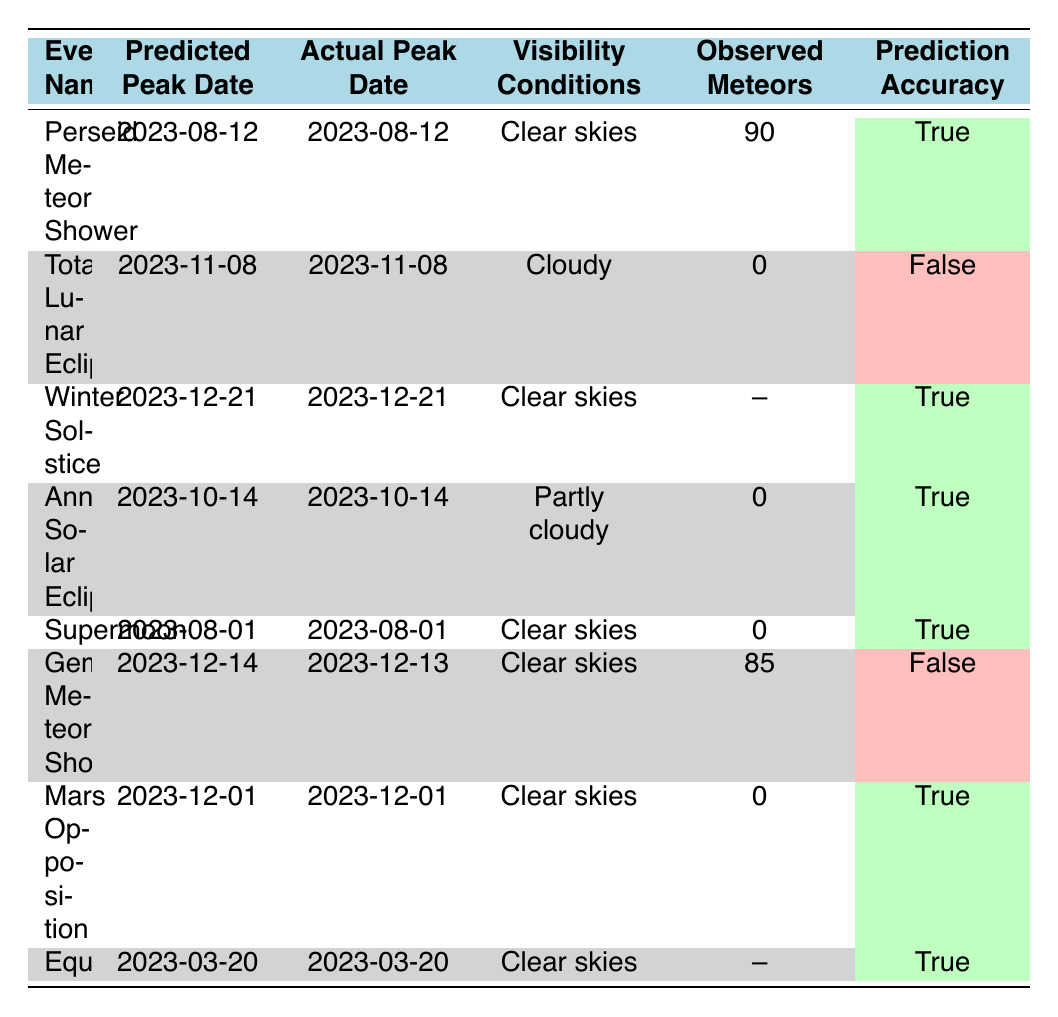What is the predicted peak date for the Perseid Meteor Shower? The table shows that the predicted peak date for the Perseid Meteor Shower is listed under the "Predicted Peak Date" column for that event.
Answer: 2023-08-12 How many observed meteors were noted during the Annular Solar Eclipse? According to the table, the number of observed meteors during the Annular Solar Eclipse is recorded in the "Observed Meteors" column, which states 0.
Answer: 0 Which celestial event had true prediction accuracy but faced cloudy visibility conditions? The "Total Lunar Eclipse" event has a prediction accuracy of false despite being accurately predicted to occur on 2023-11-08; however, it had cloudy visibility conditions.
Answer: Total Lunar Eclipse What is the difference in observed meteors between the Perseid Meteor Shower and the Geminid Meteor Shower? The Perseid Meteor Shower had 90 observed meteors, while the Geminid Meteor Shower had 85 observed meteors. To find the difference, subtract the latter from the former: 90 - 85 = 5.
Answer: 5 How many events had clear skies as visibility conditions? Looking at the visibility conditions for all events in the table, we see that the following events had clear skies: Perseid Meteor Shower, Winter Solstice, Mars Opposition, and Equinox, totaling 4 events.
Answer: 4 Was the actual peak date for the Geminid Meteor Shower different from its predicted peak date? The actual peak date for the Geminid Meteor Shower is listed as 2023-12-13, while the predicted peak date was 2023-12-14, indicating they are different dates.
Answer: Yes How many celestial events predicted had a successful accuracy rating? By counting the entries marked as 'True' in the "Prediction Accuracy" column, we find that there are 5 events that had successful predictions.
Answer: 5 What percentage of celestial events had true prediction accuracy? There are a total of 8 events, and 5 of them had true prediction accuracy. To find the percentage, divide the number of accurate predictions by the total events: (5/8) * 100 = 62.5%.
Answer: 62.5% Which celestial event is predicted to occur on the Winter Solstice date? The event listed in the table on the Winter Solstice date is simply the "Winter Solstice," with a date of 2023-12-21.
Answer: Winter Solstice 